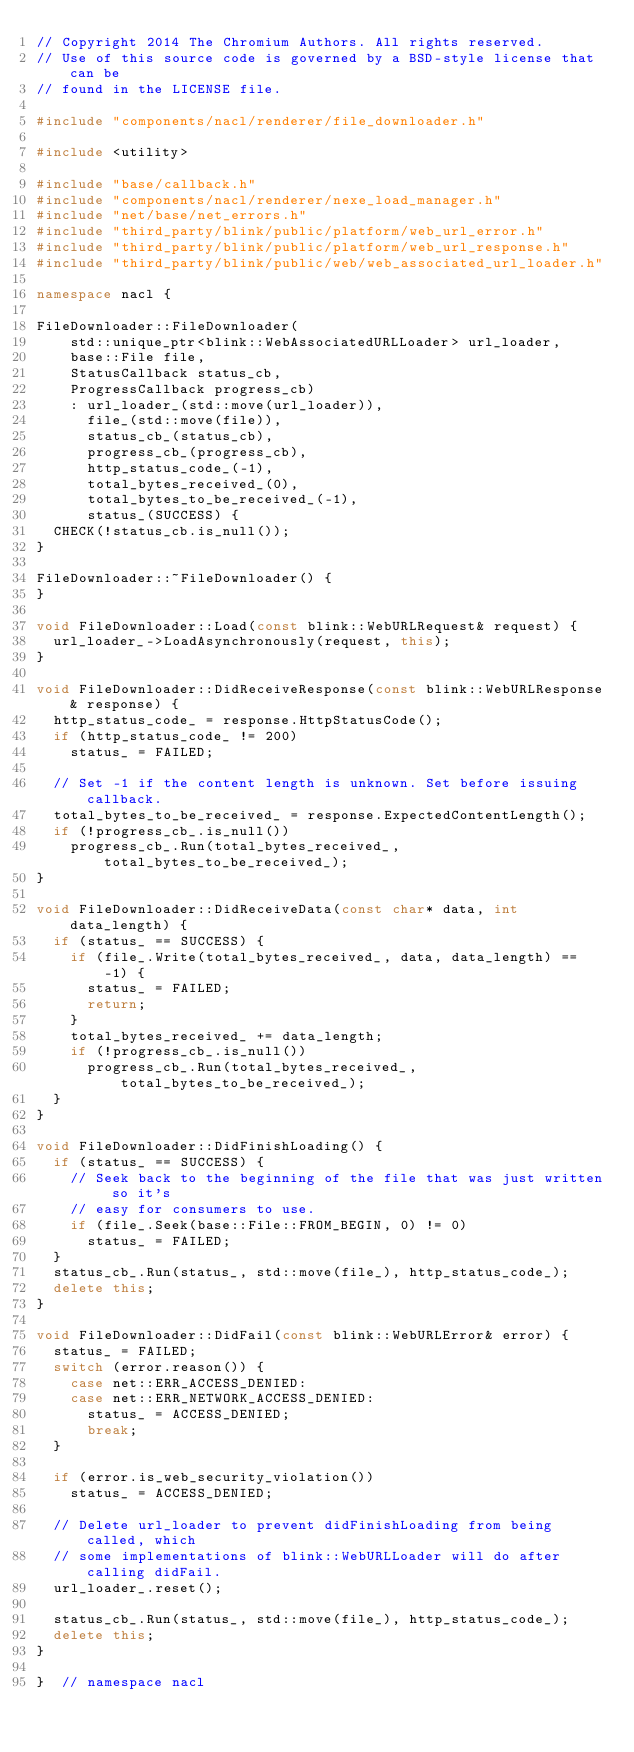Convert code to text. <code><loc_0><loc_0><loc_500><loc_500><_C++_>// Copyright 2014 The Chromium Authors. All rights reserved.
// Use of this source code is governed by a BSD-style license that can be
// found in the LICENSE file.

#include "components/nacl/renderer/file_downloader.h"

#include <utility>

#include "base/callback.h"
#include "components/nacl/renderer/nexe_load_manager.h"
#include "net/base/net_errors.h"
#include "third_party/blink/public/platform/web_url_error.h"
#include "third_party/blink/public/platform/web_url_response.h"
#include "third_party/blink/public/web/web_associated_url_loader.h"

namespace nacl {

FileDownloader::FileDownloader(
    std::unique_ptr<blink::WebAssociatedURLLoader> url_loader,
    base::File file,
    StatusCallback status_cb,
    ProgressCallback progress_cb)
    : url_loader_(std::move(url_loader)),
      file_(std::move(file)),
      status_cb_(status_cb),
      progress_cb_(progress_cb),
      http_status_code_(-1),
      total_bytes_received_(0),
      total_bytes_to_be_received_(-1),
      status_(SUCCESS) {
  CHECK(!status_cb.is_null());
}

FileDownloader::~FileDownloader() {
}

void FileDownloader::Load(const blink::WebURLRequest& request) {
  url_loader_->LoadAsynchronously(request, this);
}

void FileDownloader::DidReceiveResponse(const blink::WebURLResponse& response) {
  http_status_code_ = response.HttpStatusCode();
  if (http_status_code_ != 200)
    status_ = FAILED;

  // Set -1 if the content length is unknown. Set before issuing callback.
  total_bytes_to_be_received_ = response.ExpectedContentLength();
  if (!progress_cb_.is_null())
    progress_cb_.Run(total_bytes_received_, total_bytes_to_be_received_);
}

void FileDownloader::DidReceiveData(const char* data, int data_length) {
  if (status_ == SUCCESS) {
    if (file_.Write(total_bytes_received_, data, data_length) == -1) {
      status_ = FAILED;
      return;
    }
    total_bytes_received_ += data_length;
    if (!progress_cb_.is_null())
      progress_cb_.Run(total_bytes_received_, total_bytes_to_be_received_);
  }
}

void FileDownloader::DidFinishLoading() {
  if (status_ == SUCCESS) {
    // Seek back to the beginning of the file that was just written so it's
    // easy for consumers to use.
    if (file_.Seek(base::File::FROM_BEGIN, 0) != 0)
      status_ = FAILED;
  }
  status_cb_.Run(status_, std::move(file_), http_status_code_);
  delete this;
}

void FileDownloader::DidFail(const blink::WebURLError& error) {
  status_ = FAILED;
  switch (error.reason()) {
    case net::ERR_ACCESS_DENIED:
    case net::ERR_NETWORK_ACCESS_DENIED:
      status_ = ACCESS_DENIED;
      break;
  }

  if (error.is_web_security_violation())
    status_ = ACCESS_DENIED;

  // Delete url_loader to prevent didFinishLoading from being called, which
  // some implementations of blink::WebURLLoader will do after calling didFail.
  url_loader_.reset();

  status_cb_.Run(status_, std::move(file_), http_status_code_);
  delete this;
}

}  // namespace nacl
</code> 